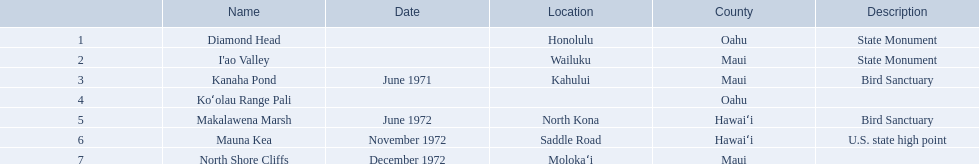What are the distinct landmark monikers? Diamond Head, I'ao Valley, Kanaha Pond, Koʻolau Range Pali, Makalawena Marsh, Mauna Kea, North Shore Cliffs. Which of these is found in the county hawai`i? Makalawena Marsh, Mauna Kea. Which of these is not mauna kea? Makalawena Marsh. 